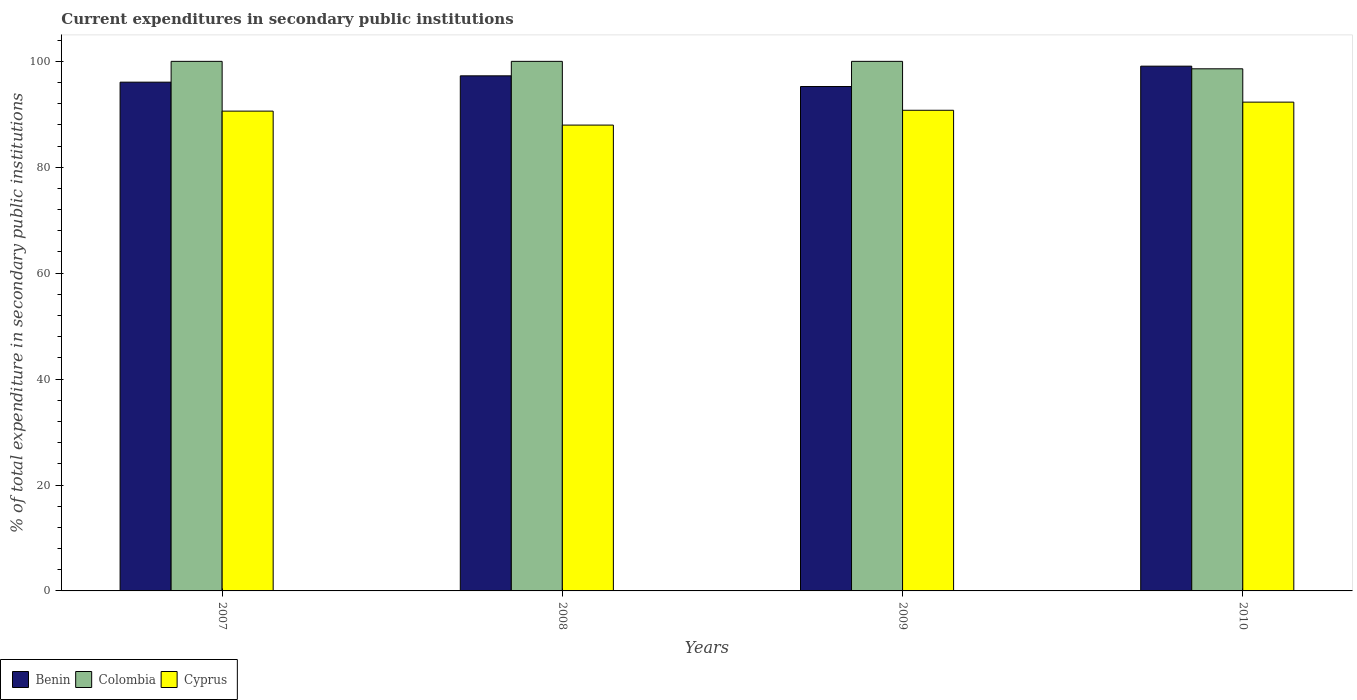How many groups of bars are there?
Offer a very short reply. 4. How many bars are there on the 3rd tick from the right?
Your answer should be compact. 3. In how many cases, is the number of bars for a given year not equal to the number of legend labels?
Give a very brief answer. 0. What is the current expenditures in secondary public institutions in Benin in 2010?
Your answer should be very brief. 99.09. Across all years, what is the maximum current expenditures in secondary public institutions in Cyprus?
Ensure brevity in your answer.  92.3. Across all years, what is the minimum current expenditures in secondary public institutions in Colombia?
Your response must be concise. 98.59. In which year was the current expenditures in secondary public institutions in Colombia maximum?
Offer a very short reply. 2007. In which year was the current expenditures in secondary public institutions in Colombia minimum?
Ensure brevity in your answer.  2010. What is the total current expenditures in secondary public institutions in Benin in the graph?
Your response must be concise. 387.68. What is the difference between the current expenditures in secondary public institutions in Benin in 2009 and that in 2010?
Ensure brevity in your answer.  -3.84. What is the difference between the current expenditures in secondary public institutions in Benin in 2007 and the current expenditures in secondary public institutions in Cyprus in 2009?
Your answer should be compact. 5.31. What is the average current expenditures in secondary public institutions in Colombia per year?
Offer a terse response. 99.65. In the year 2009, what is the difference between the current expenditures in secondary public institutions in Colombia and current expenditures in secondary public institutions in Benin?
Offer a terse response. 4.75. What is the ratio of the current expenditures in secondary public institutions in Cyprus in 2007 to that in 2008?
Keep it short and to the point. 1.03. Is the current expenditures in secondary public institutions in Benin in 2008 less than that in 2009?
Your answer should be very brief. No. Is the difference between the current expenditures in secondary public institutions in Colombia in 2008 and 2010 greater than the difference between the current expenditures in secondary public institutions in Benin in 2008 and 2010?
Make the answer very short. Yes. What is the difference between the highest and the second highest current expenditures in secondary public institutions in Colombia?
Keep it short and to the point. 0. What is the difference between the highest and the lowest current expenditures in secondary public institutions in Cyprus?
Your response must be concise. 4.33. What does the 3rd bar from the left in 2009 represents?
Give a very brief answer. Cyprus. What does the 2nd bar from the right in 2010 represents?
Your response must be concise. Colombia. Is it the case that in every year, the sum of the current expenditures in secondary public institutions in Colombia and current expenditures in secondary public institutions in Cyprus is greater than the current expenditures in secondary public institutions in Benin?
Your answer should be compact. Yes. What is the difference between two consecutive major ticks on the Y-axis?
Your answer should be compact. 20. Does the graph contain any zero values?
Your response must be concise. No. Does the graph contain grids?
Offer a terse response. No. Where does the legend appear in the graph?
Your response must be concise. Bottom left. How are the legend labels stacked?
Provide a short and direct response. Horizontal. What is the title of the graph?
Offer a very short reply. Current expenditures in secondary public institutions. What is the label or title of the Y-axis?
Give a very brief answer. % of total expenditure in secondary public institutions. What is the % of total expenditure in secondary public institutions in Benin in 2007?
Provide a short and direct response. 96.07. What is the % of total expenditure in secondary public institutions of Colombia in 2007?
Your answer should be compact. 100. What is the % of total expenditure in secondary public institutions of Cyprus in 2007?
Offer a very short reply. 90.6. What is the % of total expenditure in secondary public institutions of Benin in 2008?
Make the answer very short. 97.26. What is the % of total expenditure in secondary public institutions in Cyprus in 2008?
Offer a terse response. 87.97. What is the % of total expenditure in secondary public institutions in Benin in 2009?
Offer a terse response. 95.25. What is the % of total expenditure in secondary public institutions of Colombia in 2009?
Give a very brief answer. 100. What is the % of total expenditure in secondary public institutions in Cyprus in 2009?
Your answer should be compact. 90.76. What is the % of total expenditure in secondary public institutions in Benin in 2010?
Ensure brevity in your answer.  99.09. What is the % of total expenditure in secondary public institutions of Colombia in 2010?
Ensure brevity in your answer.  98.59. What is the % of total expenditure in secondary public institutions of Cyprus in 2010?
Your answer should be compact. 92.3. Across all years, what is the maximum % of total expenditure in secondary public institutions of Benin?
Ensure brevity in your answer.  99.09. Across all years, what is the maximum % of total expenditure in secondary public institutions of Cyprus?
Ensure brevity in your answer.  92.3. Across all years, what is the minimum % of total expenditure in secondary public institutions in Benin?
Your answer should be compact. 95.25. Across all years, what is the minimum % of total expenditure in secondary public institutions in Colombia?
Provide a succinct answer. 98.59. Across all years, what is the minimum % of total expenditure in secondary public institutions in Cyprus?
Keep it short and to the point. 87.97. What is the total % of total expenditure in secondary public institutions of Benin in the graph?
Provide a short and direct response. 387.68. What is the total % of total expenditure in secondary public institutions of Colombia in the graph?
Ensure brevity in your answer.  398.59. What is the total % of total expenditure in secondary public institutions in Cyprus in the graph?
Keep it short and to the point. 361.63. What is the difference between the % of total expenditure in secondary public institutions of Benin in 2007 and that in 2008?
Provide a succinct answer. -1.19. What is the difference between the % of total expenditure in secondary public institutions in Colombia in 2007 and that in 2008?
Provide a succinct answer. 0. What is the difference between the % of total expenditure in secondary public institutions of Cyprus in 2007 and that in 2008?
Your answer should be very brief. 2.64. What is the difference between the % of total expenditure in secondary public institutions in Benin in 2007 and that in 2009?
Your answer should be compact. 0.82. What is the difference between the % of total expenditure in secondary public institutions of Cyprus in 2007 and that in 2009?
Your answer should be compact. -0.16. What is the difference between the % of total expenditure in secondary public institutions of Benin in 2007 and that in 2010?
Offer a very short reply. -3.02. What is the difference between the % of total expenditure in secondary public institutions in Colombia in 2007 and that in 2010?
Your answer should be compact. 1.41. What is the difference between the % of total expenditure in secondary public institutions of Cyprus in 2007 and that in 2010?
Your answer should be very brief. -1.7. What is the difference between the % of total expenditure in secondary public institutions in Benin in 2008 and that in 2009?
Ensure brevity in your answer.  2.02. What is the difference between the % of total expenditure in secondary public institutions in Cyprus in 2008 and that in 2009?
Ensure brevity in your answer.  -2.8. What is the difference between the % of total expenditure in secondary public institutions of Benin in 2008 and that in 2010?
Offer a very short reply. -1.83. What is the difference between the % of total expenditure in secondary public institutions of Colombia in 2008 and that in 2010?
Provide a short and direct response. 1.41. What is the difference between the % of total expenditure in secondary public institutions in Cyprus in 2008 and that in 2010?
Provide a succinct answer. -4.33. What is the difference between the % of total expenditure in secondary public institutions in Benin in 2009 and that in 2010?
Give a very brief answer. -3.85. What is the difference between the % of total expenditure in secondary public institutions of Colombia in 2009 and that in 2010?
Your answer should be compact. 1.41. What is the difference between the % of total expenditure in secondary public institutions in Cyprus in 2009 and that in 2010?
Provide a succinct answer. -1.54. What is the difference between the % of total expenditure in secondary public institutions of Benin in 2007 and the % of total expenditure in secondary public institutions of Colombia in 2008?
Your answer should be very brief. -3.93. What is the difference between the % of total expenditure in secondary public institutions of Benin in 2007 and the % of total expenditure in secondary public institutions of Cyprus in 2008?
Provide a short and direct response. 8.11. What is the difference between the % of total expenditure in secondary public institutions of Colombia in 2007 and the % of total expenditure in secondary public institutions of Cyprus in 2008?
Your response must be concise. 12.03. What is the difference between the % of total expenditure in secondary public institutions of Benin in 2007 and the % of total expenditure in secondary public institutions of Colombia in 2009?
Ensure brevity in your answer.  -3.93. What is the difference between the % of total expenditure in secondary public institutions in Benin in 2007 and the % of total expenditure in secondary public institutions in Cyprus in 2009?
Your answer should be compact. 5.31. What is the difference between the % of total expenditure in secondary public institutions in Colombia in 2007 and the % of total expenditure in secondary public institutions in Cyprus in 2009?
Offer a terse response. 9.24. What is the difference between the % of total expenditure in secondary public institutions of Benin in 2007 and the % of total expenditure in secondary public institutions of Colombia in 2010?
Offer a terse response. -2.52. What is the difference between the % of total expenditure in secondary public institutions in Benin in 2007 and the % of total expenditure in secondary public institutions in Cyprus in 2010?
Your response must be concise. 3.77. What is the difference between the % of total expenditure in secondary public institutions in Colombia in 2007 and the % of total expenditure in secondary public institutions in Cyprus in 2010?
Your response must be concise. 7.7. What is the difference between the % of total expenditure in secondary public institutions of Benin in 2008 and the % of total expenditure in secondary public institutions of Colombia in 2009?
Your answer should be very brief. -2.74. What is the difference between the % of total expenditure in secondary public institutions in Benin in 2008 and the % of total expenditure in secondary public institutions in Cyprus in 2009?
Your answer should be very brief. 6.5. What is the difference between the % of total expenditure in secondary public institutions of Colombia in 2008 and the % of total expenditure in secondary public institutions of Cyprus in 2009?
Your response must be concise. 9.24. What is the difference between the % of total expenditure in secondary public institutions in Benin in 2008 and the % of total expenditure in secondary public institutions in Colombia in 2010?
Your answer should be compact. -1.33. What is the difference between the % of total expenditure in secondary public institutions of Benin in 2008 and the % of total expenditure in secondary public institutions of Cyprus in 2010?
Ensure brevity in your answer.  4.97. What is the difference between the % of total expenditure in secondary public institutions of Colombia in 2008 and the % of total expenditure in secondary public institutions of Cyprus in 2010?
Ensure brevity in your answer.  7.7. What is the difference between the % of total expenditure in secondary public institutions in Benin in 2009 and the % of total expenditure in secondary public institutions in Colombia in 2010?
Offer a terse response. -3.34. What is the difference between the % of total expenditure in secondary public institutions in Benin in 2009 and the % of total expenditure in secondary public institutions in Cyprus in 2010?
Make the answer very short. 2.95. What is the difference between the % of total expenditure in secondary public institutions of Colombia in 2009 and the % of total expenditure in secondary public institutions of Cyprus in 2010?
Your response must be concise. 7.7. What is the average % of total expenditure in secondary public institutions of Benin per year?
Your answer should be compact. 96.92. What is the average % of total expenditure in secondary public institutions in Colombia per year?
Your answer should be compact. 99.65. What is the average % of total expenditure in secondary public institutions in Cyprus per year?
Your response must be concise. 90.41. In the year 2007, what is the difference between the % of total expenditure in secondary public institutions of Benin and % of total expenditure in secondary public institutions of Colombia?
Keep it short and to the point. -3.93. In the year 2007, what is the difference between the % of total expenditure in secondary public institutions of Benin and % of total expenditure in secondary public institutions of Cyprus?
Your answer should be very brief. 5.47. In the year 2007, what is the difference between the % of total expenditure in secondary public institutions in Colombia and % of total expenditure in secondary public institutions in Cyprus?
Provide a succinct answer. 9.4. In the year 2008, what is the difference between the % of total expenditure in secondary public institutions of Benin and % of total expenditure in secondary public institutions of Colombia?
Provide a short and direct response. -2.74. In the year 2008, what is the difference between the % of total expenditure in secondary public institutions of Benin and % of total expenditure in secondary public institutions of Cyprus?
Your answer should be compact. 9.3. In the year 2008, what is the difference between the % of total expenditure in secondary public institutions in Colombia and % of total expenditure in secondary public institutions in Cyprus?
Provide a succinct answer. 12.03. In the year 2009, what is the difference between the % of total expenditure in secondary public institutions of Benin and % of total expenditure in secondary public institutions of Colombia?
Ensure brevity in your answer.  -4.75. In the year 2009, what is the difference between the % of total expenditure in secondary public institutions in Benin and % of total expenditure in secondary public institutions in Cyprus?
Keep it short and to the point. 4.48. In the year 2009, what is the difference between the % of total expenditure in secondary public institutions of Colombia and % of total expenditure in secondary public institutions of Cyprus?
Offer a terse response. 9.24. In the year 2010, what is the difference between the % of total expenditure in secondary public institutions of Benin and % of total expenditure in secondary public institutions of Colombia?
Your response must be concise. 0.5. In the year 2010, what is the difference between the % of total expenditure in secondary public institutions of Benin and % of total expenditure in secondary public institutions of Cyprus?
Make the answer very short. 6.79. In the year 2010, what is the difference between the % of total expenditure in secondary public institutions of Colombia and % of total expenditure in secondary public institutions of Cyprus?
Your answer should be very brief. 6.29. What is the ratio of the % of total expenditure in secondary public institutions in Colombia in 2007 to that in 2008?
Offer a very short reply. 1. What is the ratio of the % of total expenditure in secondary public institutions of Cyprus in 2007 to that in 2008?
Offer a terse response. 1.03. What is the ratio of the % of total expenditure in secondary public institutions of Benin in 2007 to that in 2009?
Keep it short and to the point. 1.01. What is the ratio of the % of total expenditure in secondary public institutions of Benin in 2007 to that in 2010?
Ensure brevity in your answer.  0.97. What is the ratio of the % of total expenditure in secondary public institutions in Colombia in 2007 to that in 2010?
Your response must be concise. 1.01. What is the ratio of the % of total expenditure in secondary public institutions in Cyprus in 2007 to that in 2010?
Provide a short and direct response. 0.98. What is the ratio of the % of total expenditure in secondary public institutions in Benin in 2008 to that in 2009?
Make the answer very short. 1.02. What is the ratio of the % of total expenditure in secondary public institutions in Colombia in 2008 to that in 2009?
Provide a succinct answer. 1. What is the ratio of the % of total expenditure in secondary public institutions in Cyprus in 2008 to that in 2009?
Your answer should be compact. 0.97. What is the ratio of the % of total expenditure in secondary public institutions in Benin in 2008 to that in 2010?
Your answer should be very brief. 0.98. What is the ratio of the % of total expenditure in secondary public institutions of Colombia in 2008 to that in 2010?
Offer a terse response. 1.01. What is the ratio of the % of total expenditure in secondary public institutions of Cyprus in 2008 to that in 2010?
Your answer should be very brief. 0.95. What is the ratio of the % of total expenditure in secondary public institutions in Benin in 2009 to that in 2010?
Give a very brief answer. 0.96. What is the ratio of the % of total expenditure in secondary public institutions in Colombia in 2009 to that in 2010?
Give a very brief answer. 1.01. What is the ratio of the % of total expenditure in secondary public institutions of Cyprus in 2009 to that in 2010?
Provide a succinct answer. 0.98. What is the difference between the highest and the second highest % of total expenditure in secondary public institutions of Benin?
Make the answer very short. 1.83. What is the difference between the highest and the second highest % of total expenditure in secondary public institutions of Colombia?
Keep it short and to the point. 0. What is the difference between the highest and the second highest % of total expenditure in secondary public institutions in Cyprus?
Your answer should be very brief. 1.54. What is the difference between the highest and the lowest % of total expenditure in secondary public institutions in Benin?
Your answer should be compact. 3.85. What is the difference between the highest and the lowest % of total expenditure in secondary public institutions in Colombia?
Give a very brief answer. 1.41. What is the difference between the highest and the lowest % of total expenditure in secondary public institutions in Cyprus?
Your response must be concise. 4.33. 